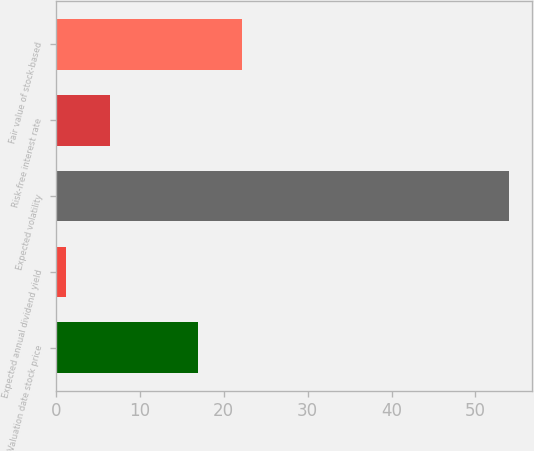Convert chart to OTSL. <chart><loc_0><loc_0><loc_500><loc_500><bar_chart><fcel>Valuation date stock price<fcel>Expected annual dividend yield<fcel>Expected volatility<fcel>Risk-free interest rate<fcel>Fair value of stock-based<nl><fcel>16.93<fcel>1.2<fcel>54<fcel>6.48<fcel>22.21<nl></chart> 